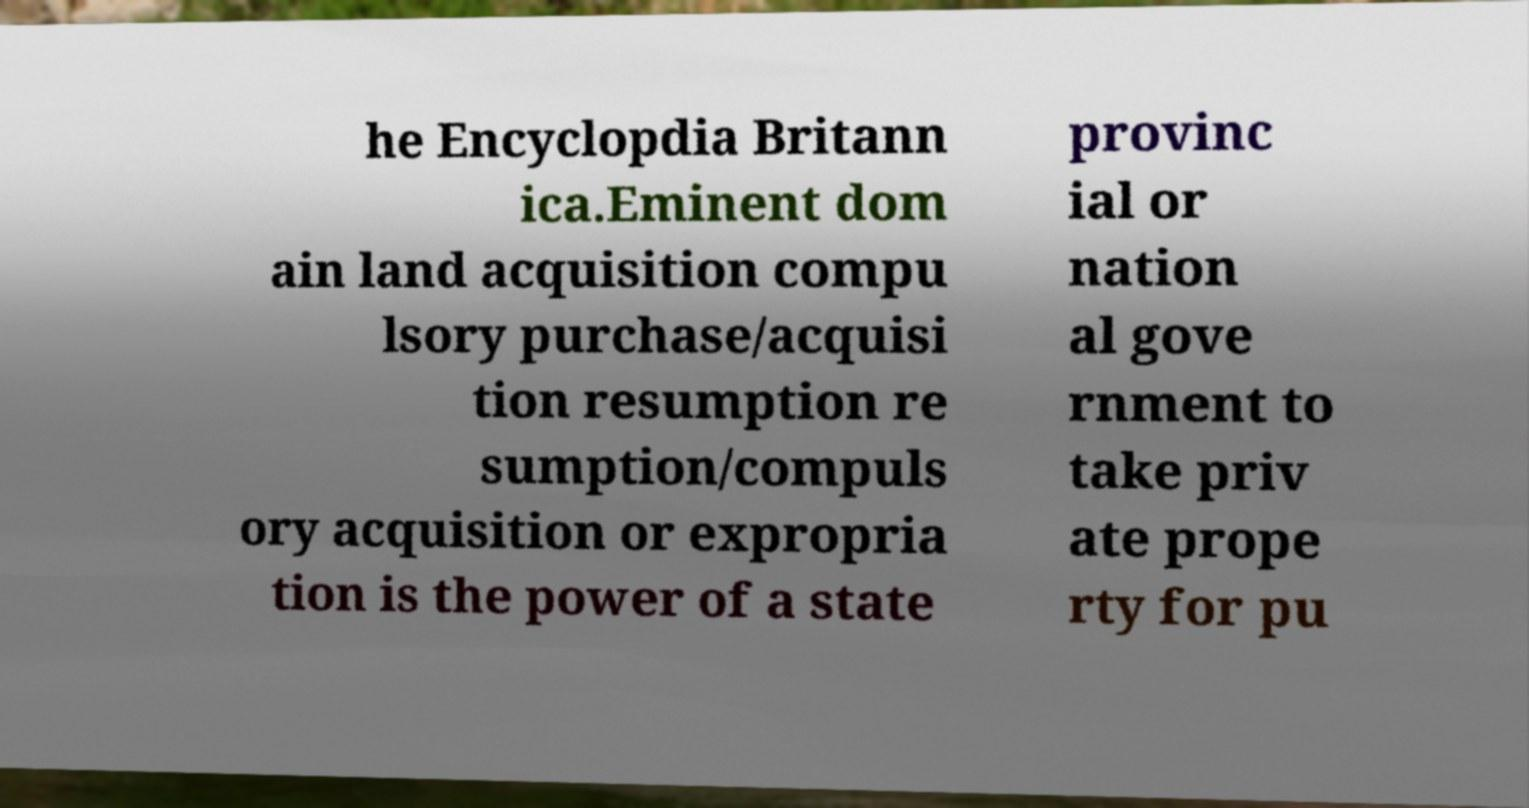For documentation purposes, I need the text within this image transcribed. Could you provide that? he Encyclopdia Britann ica.Eminent dom ain land acquisition compu lsory purchase/acquisi tion resumption re sumption/compuls ory acquisition or expropria tion is the power of a state provinc ial or nation al gove rnment to take priv ate prope rty for pu 